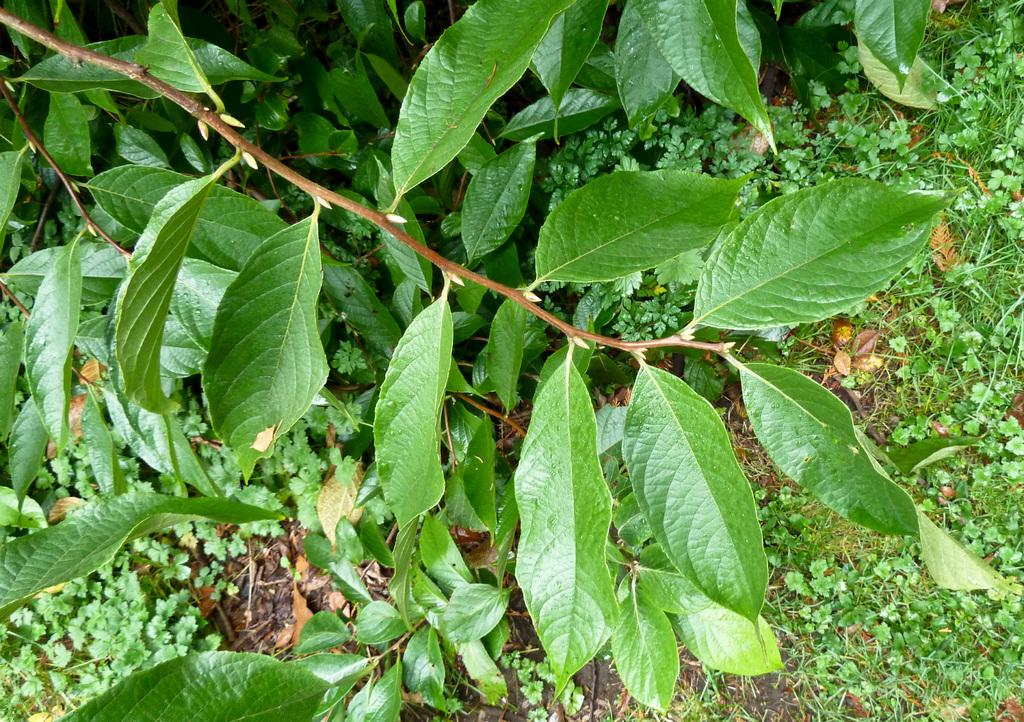What type of living organisms can be seen in the image? Plants and plant saplings are visible in the image. Can you describe the vegetation on the path in the image? There is grass on a path in the image. What color is the plate on the left side of the image? There is no plate present in the image. What type of offer is being made by the plants in the image? The plants in the image are not making any offers; they are simply growing and existing in their environment. 